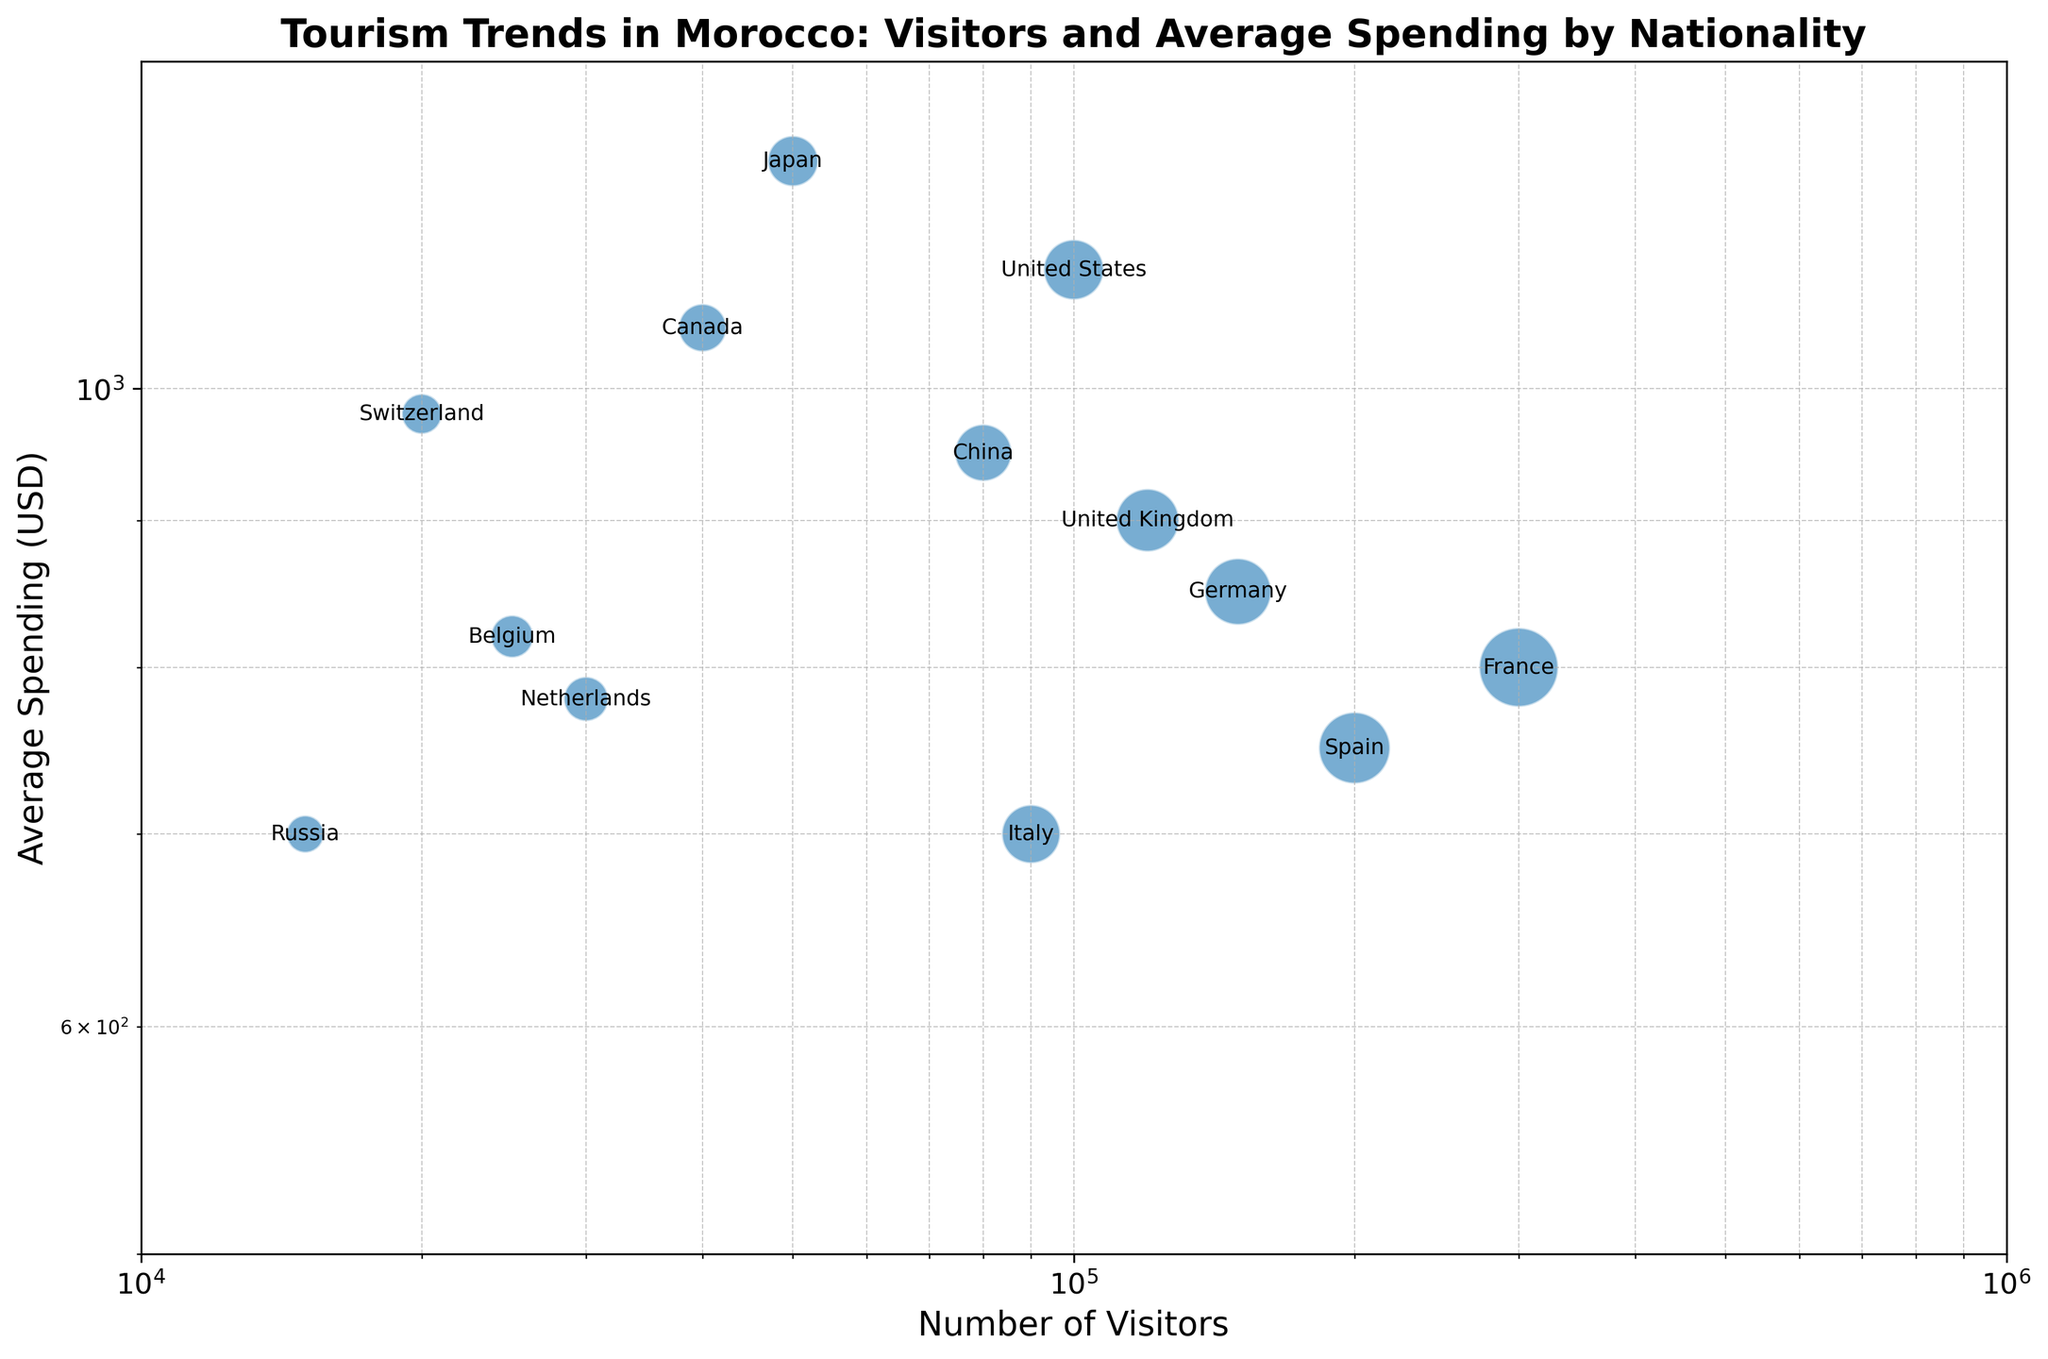Which nationality has the highest average spending? The figure shows that Japan has the highest average spending among all nationalities, with an average of 1200 USD.
Answer: Japan Which nationality has the largest number of visitors? According to the figure, France has the largest number of visitors, with 300,000 visitors.
Answer: France Compare the average spending of visitors from the United States to those from Canada. The average spending of visitors from the United States is 1100 USD, while the average spending of visitors from Canada is 1050 USD. Therefore, visitors from the United States spend more on average than those from Canada.
Answer: United States How does the number of visitors from Germany compare to those from China, and what are their respective average spendings? Germany has 150,000 visitors, which is higher than China's 80,000 visitors. The average spending for German visitors is 850 USD, while for Chinese visitors, it is 950 USD.
Answer: Germany: 150,000 visitors, 850 USD; China: 80,000 visitors, 950 USD Calculate the total number of visitors from France, Spain, and Germany. France has 300,000 visitors, Spain has 200,000 visitors, and Germany has 150,000 visitors. The total number of visitors from these three countries is 300,000 + 200,000 + 150,000 = 650,000.
Answer: 650,000 Which nationality has the lowest average spending, and how much is it? According to the figure, Italy and Russia both have the lowest average spending, with an expenditure of 700 USD.
Answer: Italy and Russia Between Belgium and Switzerland, which nationality has higher average spending and by how much? Belgium has an average spending of 820 USD, and Switzerland has an average spending of 980 USD. The difference in average spending is 980 - 820 = 160 USD.
Answer: Switzerland, 160 USD How does the number of visitors correlate with their average spending for the top five nationalities? The top five nationalities by visitor count are France, Spain, Germany, the United Kingdom, and the United States. The average spending does not show a clear linear correlation with the number of visitors, as the average spending varies among these countries. Specifically, the United States has the highest average spending among the top five despite not having the highest number of visitors.
Answer: No clear correlation What is the sum of average spending for all nationalities listed? To calculate the sum of average spending, we add up the average spending of all nationalities: 800 + 750 + 850 + 900 + 1100 + 700 + 950 + 1200 + 1050 + 780 + 820 + 980 + 700 = 12580 USD.
Answer: 12580 USD Which nationality has a higher number of visitors, Japan or China, and what is the difference? China has 80,000 visitors, whereas Japan has 50,000 visitors. The difference in the number of visitors is 80,000 - 50,000 = 30,000.
Answer: China, 30,000 